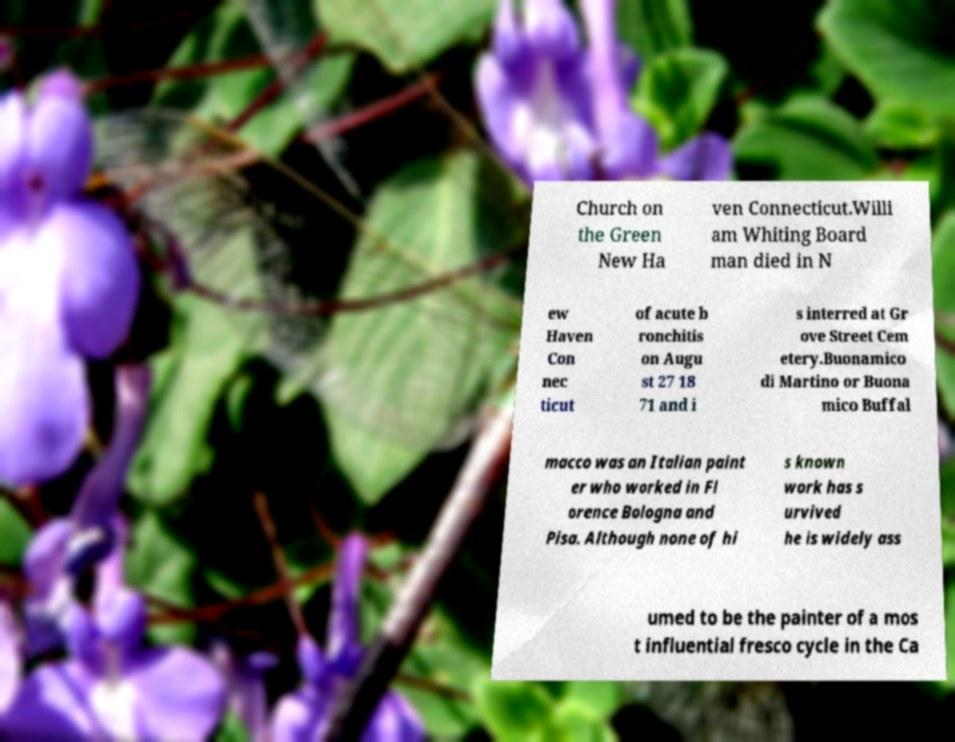Could you extract and type out the text from this image? Church on the Green New Ha ven Connecticut.Willi am Whiting Board man died in N ew Haven Con nec ticut of acute b ronchitis on Augu st 27 18 71 and i s interred at Gr ove Street Cem etery.Buonamico di Martino or Buona mico Buffal macco was an Italian paint er who worked in Fl orence Bologna and Pisa. Although none of hi s known work has s urvived he is widely ass umed to be the painter of a mos t influential fresco cycle in the Ca 